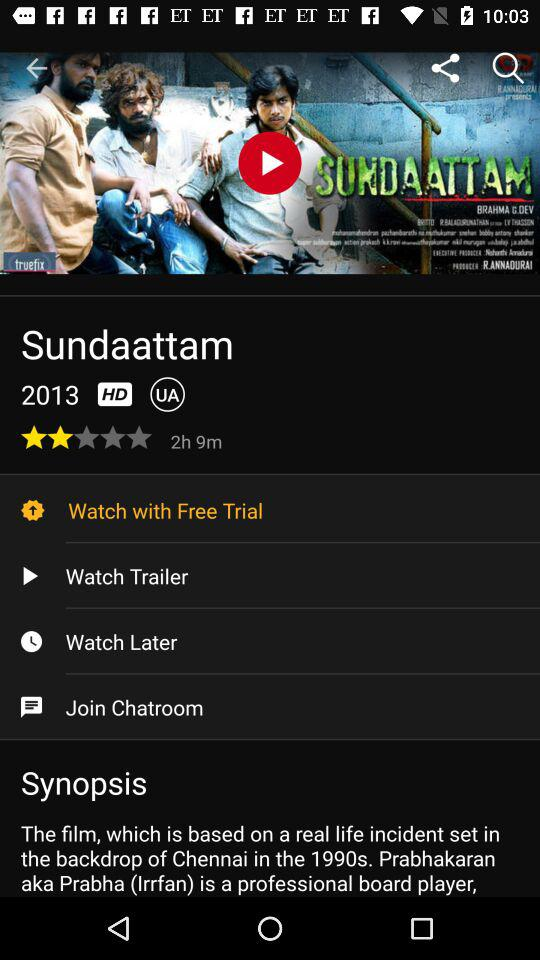What is the movie's name? The movie's name is "Sundaattam". 